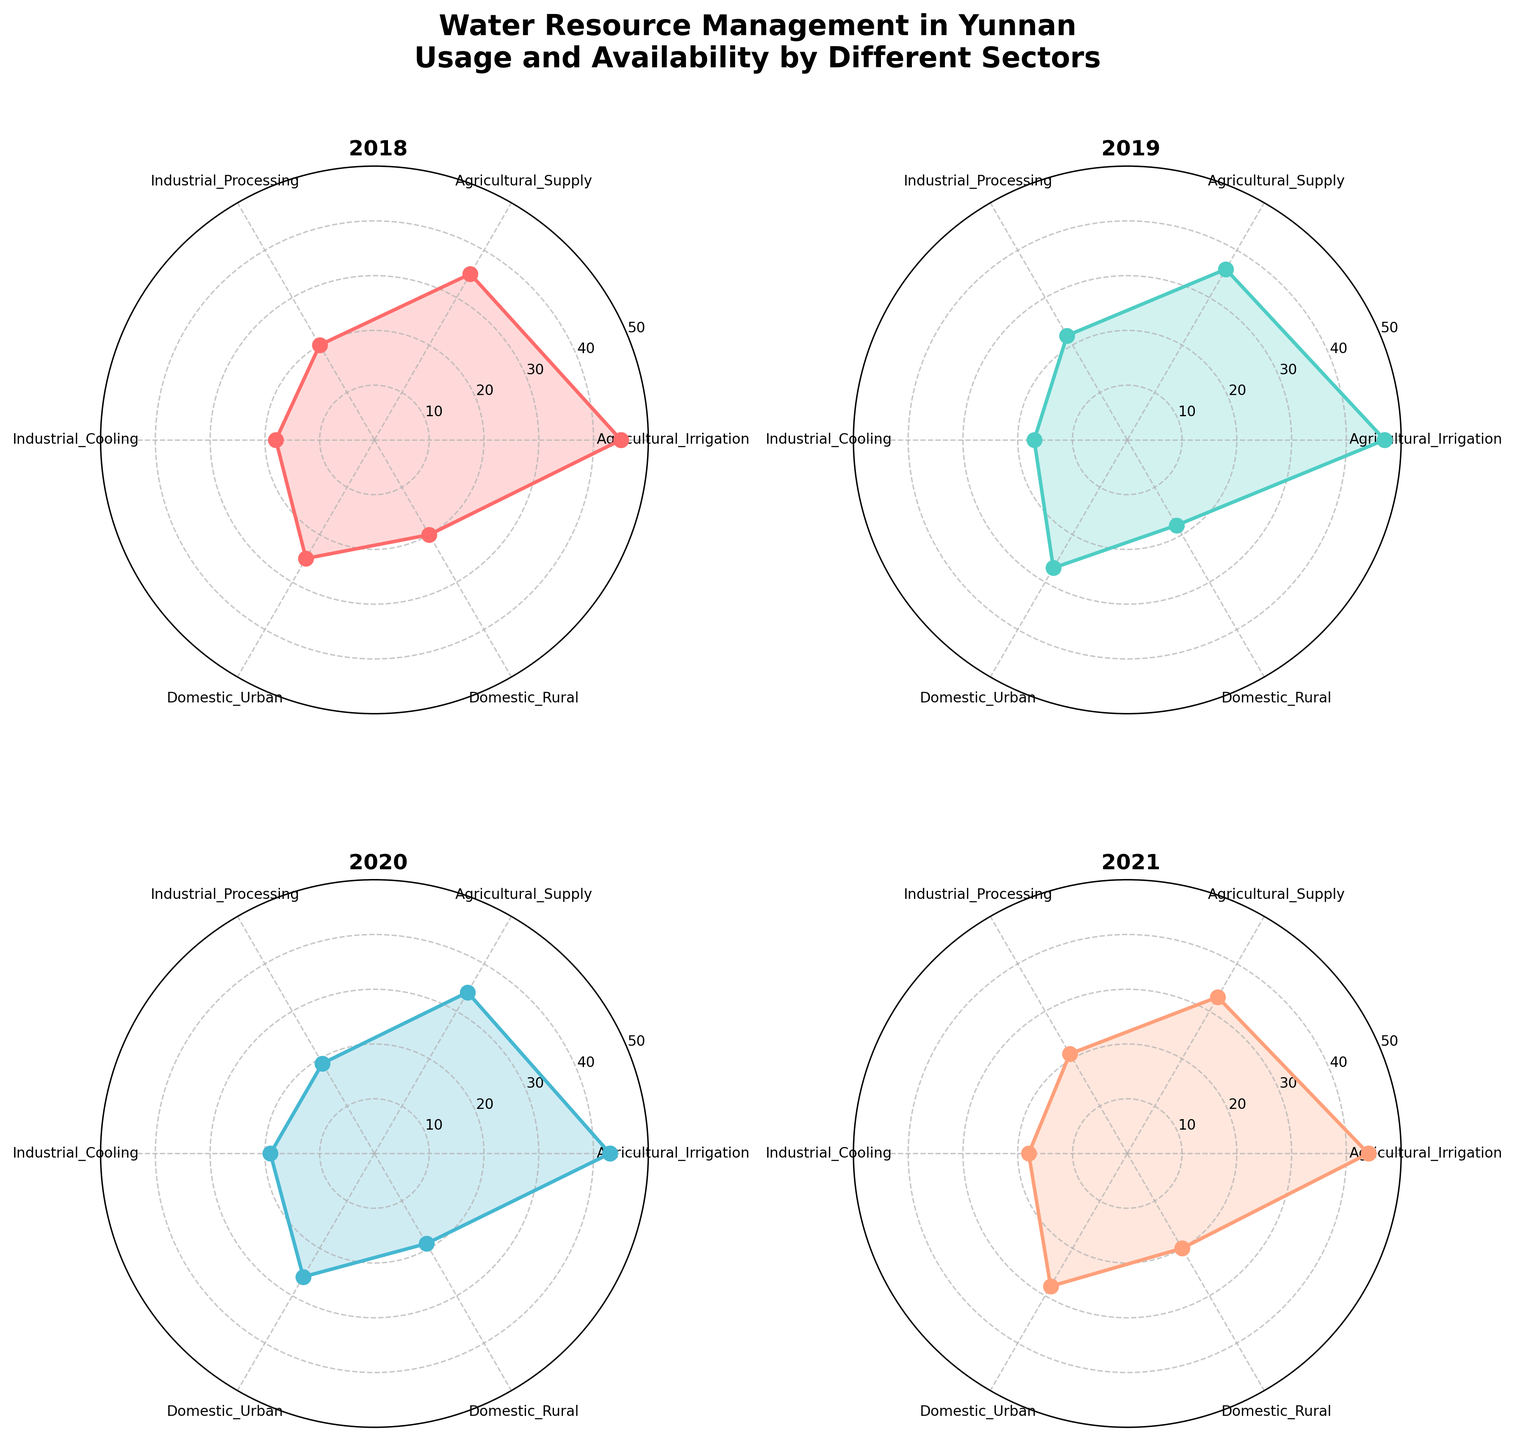What's the title of the subplot chart? The title is typically placed at the top of the figure. Here, it reads, "Water Resource Management in Yunnan\nUsage and Availability by Different Sectors."
Answer: Water Resource Management in Yunnan\nUsage and Availability by Different Sectors What are the sectors listed on the radar charts? The sectors can be read directly from the labels around the radar charts: Agricultural_Irrigation, Agricultural_Supply, Industrial_Processing, Industrial_Cooling, Domestic_Urban, and Domestic_Rural.
Answer: Agricultural_Irrigation, Agricultural_Supply, Industrial_Processing, Industrial_Cooling, Domestic_Urban, Domestic_Rural Which year has the highest usage in the Domestic_Urban sector? By observing the radar charts, Domestic_Urban sector usage is highest in 2021, with a value of 28.
Answer: 2021 How does the water usage for Agricultural_Irrigation compare between 2018 and 2020? By looking at the radar chart values for Agricultural_Irrigation in 2018 and 2020, they are 45 and 43, respectively. 45 is higher than 43.
Answer: 2018 has a higher value What's the lowest value for Industrial_Cooling across all years? Checking the values for Industrial_Cooling in each year: 18 in 2018, 17 in 2019, 19 in 2020, and 18 in 2021, the lowest value is 17 in 2019.
Answer: 17 Which sector shows the most consistent usage over the years? By comparing the fluctuations across all sectors, Agricultural_Supply shows the least fluctuation: 35, 36, 34, 33.
Answer: Agricultural_Supply What is the mean value of water usage for Domestic_Rural in all years? Summing the values of Domestic_Rural across all years: 20 (2018) + 18 (2019) + 19 (2020) + 20 (2021) equals 77. The mean is 77 divided by 4, which is 19.25.
Answer: 19.25 Which sector and year combination experienced the lowest water usage? Observing the lowest points in all subplots, Industrial_Cooling in 2019 is the lowest with a usage value of 17.
Answer: Industrial_Cooling in 2019 Which year had the highest overall water usage in all sectors combined? Summing up the values for each year: 2018 (163), 2019 (167), 2020 (160), 2021 (164). The highest sum is 167 in 2019.
Answer: 2019 